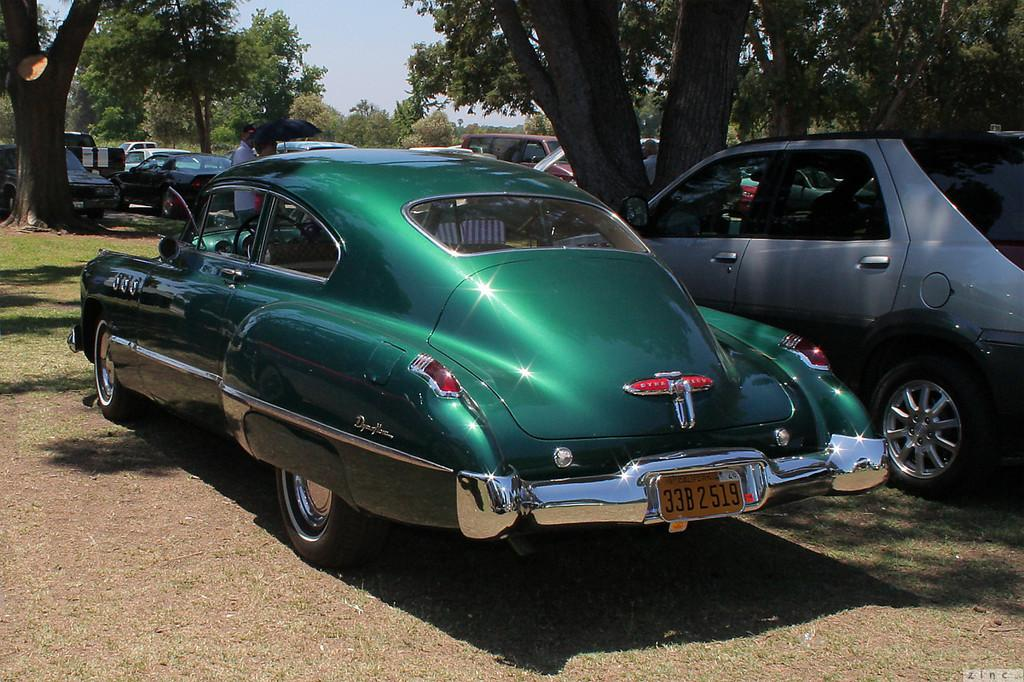What type of vehicles can be seen in the image? There are cars in the image. What natural elements are present in the image? There are trees and grass in the image. Are there any people in the image? Yes, there are people in the image. Can you describe the person in the center of the image? There is a person holding an umbrella in the center of the image. What is the weather like in the image? It is sunny in the image. What verse is being recited by the tramp sitting on the sofa in the image? There is no tramp or sofa present in the image. What type of creature is shown interacting with the person holding the umbrella in the image? There is no creature shown interacting with the person holding the umbrella in the image; only the person and the umbrella are present. 